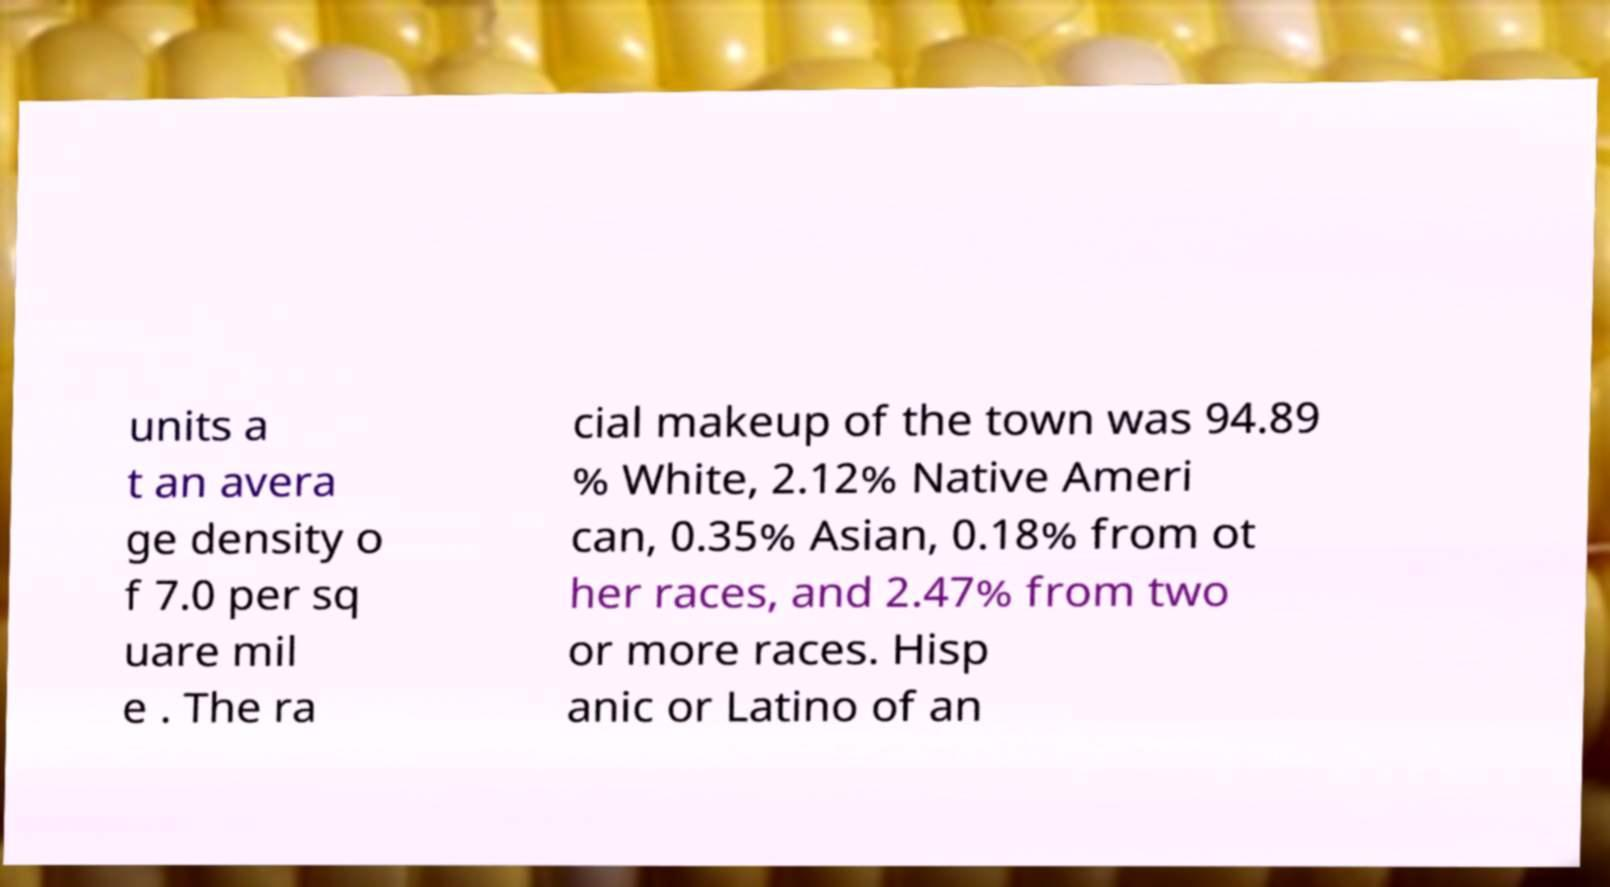There's text embedded in this image that I need extracted. Can you transcribe it verbatim? units a t an avera ge density o f 7.0 per sq uare mil e . The ra cial makeup of the town was 94.89 % White, 2.12% Native Ameri can, 0.35% Asian, 0.18% from ot her races, and 2.47% from two or more races. Hisp anic or Latino of an 